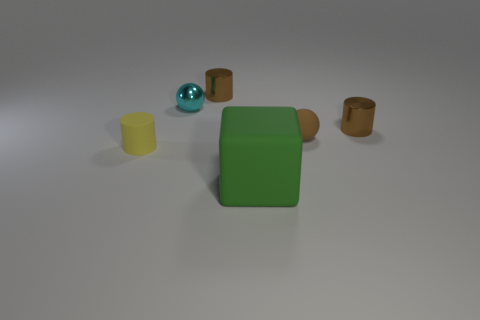What is the material of the other tiny object that is the same shape as the tiny cyan thing?
Make the answer very short. Rubber. Is the material of the small brown ball the same as the tiny cyan ball?
Provide a succinct answer. No. Is the number of small brown metal cylinders on the left side of the tiny brown sphere greater than the number of small brown metal things?
Provide a short and direct response. No. There is a small sphere that is in front of the tiny brown metal cylinder that is in front of the small brown thing that is on the left side of the green cube; what is it made of?
Offer a terse response. Rubber. What number of objects are either green cylinders or things behind the small yellow cylinder?
Your answer should be very brief. 4. There is a metal thing that is behind the cyan ball; is its color the same as the small matte ball?
Ensure brevity in your answer.  Yes. Is the number of small metal cylinders that are to the right of the cyan metal sphere greater than the number of cyan objects on the left side of the rubber cylinder?
Offer a very short reply. Yes. Are there any other things of the same color as the rubber cylinder?
Make the answer very short. No. What number of objects are brown spheres or brown cylinders?
Give a very brief answer. 3. There is a brown shiny cylinder behind the cyan shiny thing; is it the same size as the yellow object?
Your answer should be compact. Yes. 